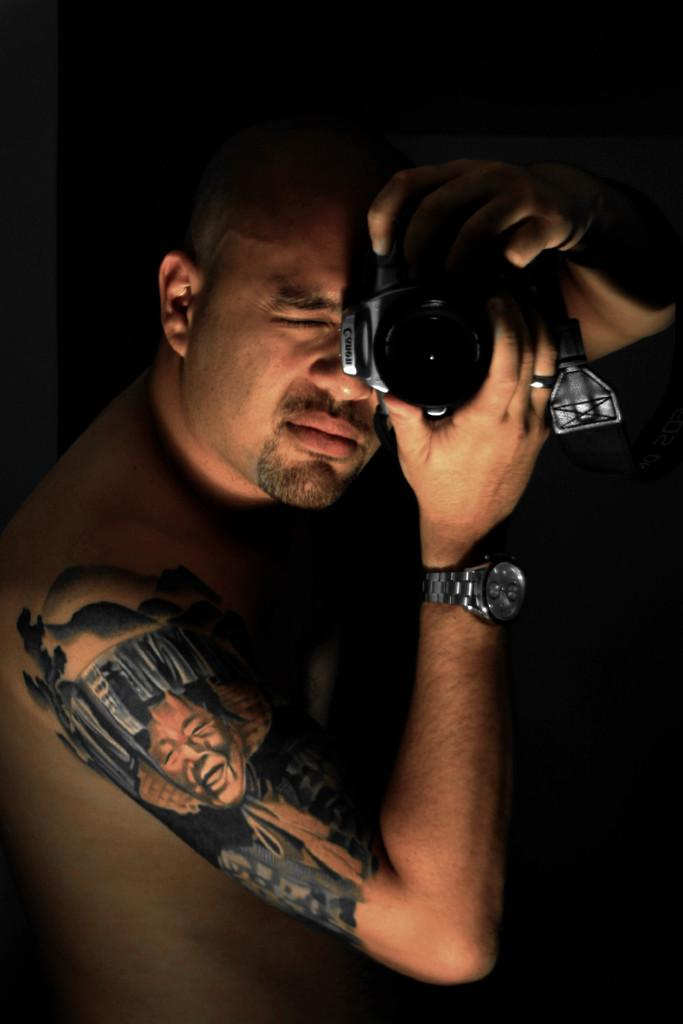Who is the main subject in the image? There is a man in the image. What is the man holding in the image? The man is holding a camera. What accessory is the man wearing in the image? The man is wearing a watch. Can you describe any unique features on the man's body in the image? The man has a tattoo on his right hand. How many sisters does the man have in the image? There is no information about the man's sisters in the image. What type of cushion is the man sitting on in the image? There is no cushion present in the image; the man is standing. 